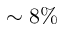<formula> <loc_0><loc_0><loc_500><loc_500>\sim 8 \%</formula> 